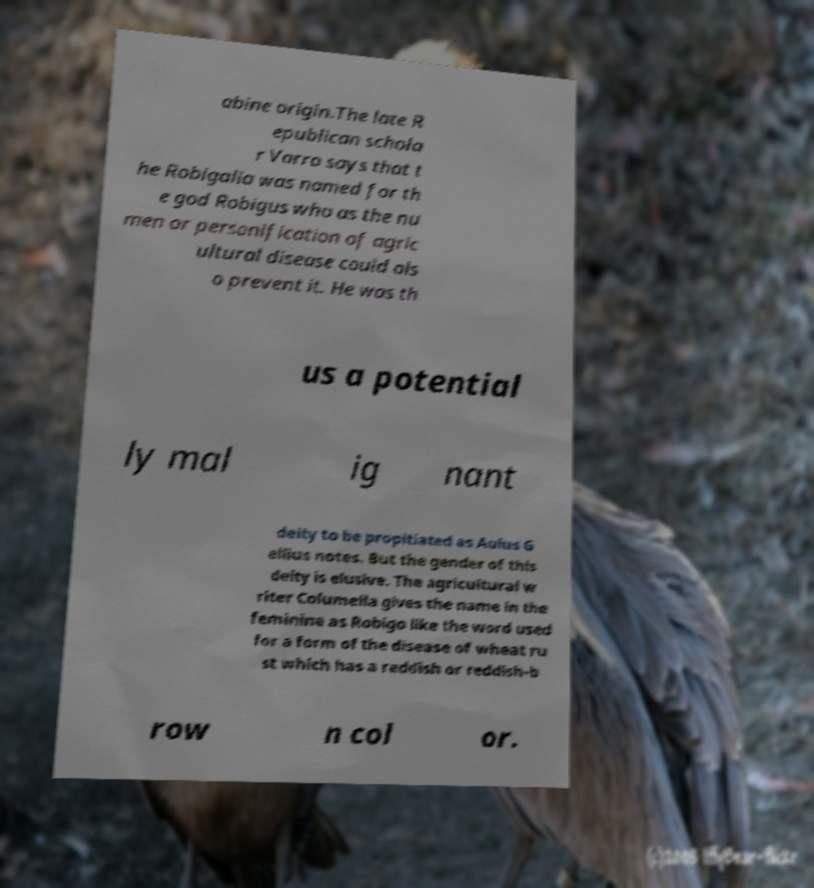Can you accurately transcribe the text from the provided image for me? abine origin.The late R epublican schola r Varro says that t he Robigalia was named for th e god Robigus who as the nu men or personification of agric ultural disease could als o prevent it. He was th us a potential ly mal ig nant deity to be propitiated as Aulus G ellius notes. But the gender of this deity is elusive. The agricultural w riter Columella gives the name in the feminine as Robigo like the word used for a form of the disease of wheat ru st which has a reddish or reddish-b row n col or. 